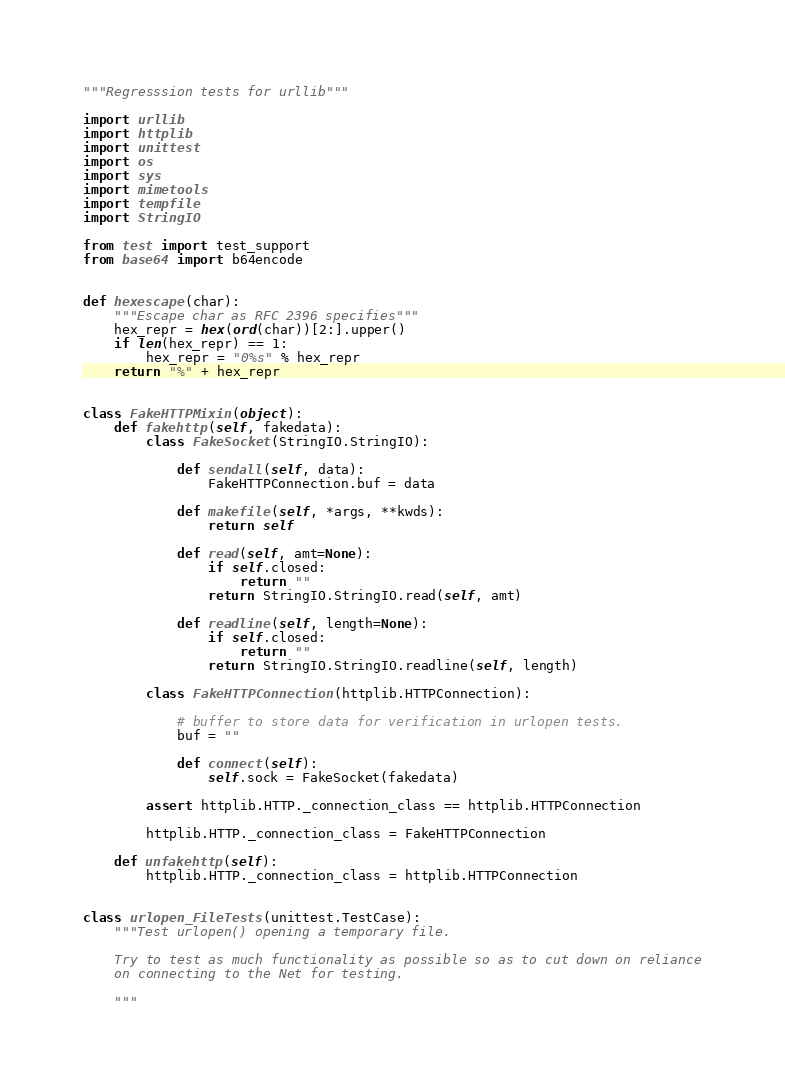<code> <loc_0><loc_0><loc_500><loc_500><_Python_>"""Regresssion tests for urllib"""

import urllib
import httplib
import unittest
import os
import sys
import mimetools
import tempfile
import StringIO

from test import test_support
from base64 import b64encode


def hexescape(char):
    """Escape char as RFC 2396 specifies"""
    hex_repr = hex(ord(char))[2:].upper()
    if len(hex_repr) == 1:
        hex_repr = "0%s" % hex_repr
    return "%" + hex_repr


class FakeHTTPMixin(object):
    def fakehttp(self, fakedata):
        class FakeSocket(StringIO.StringIO):

            def sendall(self, data):
                FakeHTTPConnection.buf = data

            def makefile(self, *args, **kwds):
                return self

            def read(self, amt=None):
                if self.closed:
                    return ""
                return StringIO.StringIO.read(self, amt)

            def readline(self, length=None):
                if self.closed:
                    return ""
                return StringIO.StringIO.readline(self, length)

        class FakeHTTPConnection(httplib.HTTPConnection):

            # buffer to store data for verification in urlopen tests.
            buf = ""

            def connect(self):
                self.sock = FakeSocket(fakedata)

        assert httplib.HTTP._connection_class == httplib.HTTPConnection

        httplib.HTTP._connection_class = FakeHTTPConnection

    def unfakehttp(self):
        httplib.HTTP._connection_class = httplib.HTTPConnection


class urlopen_FileTests(unittest.TestCase):
    """Test urlopen() opening a temporary file.

    Try to test as much functionality as possible so as to cut down on reliance
    on connecting to the Net for testing.

    """
</code> 